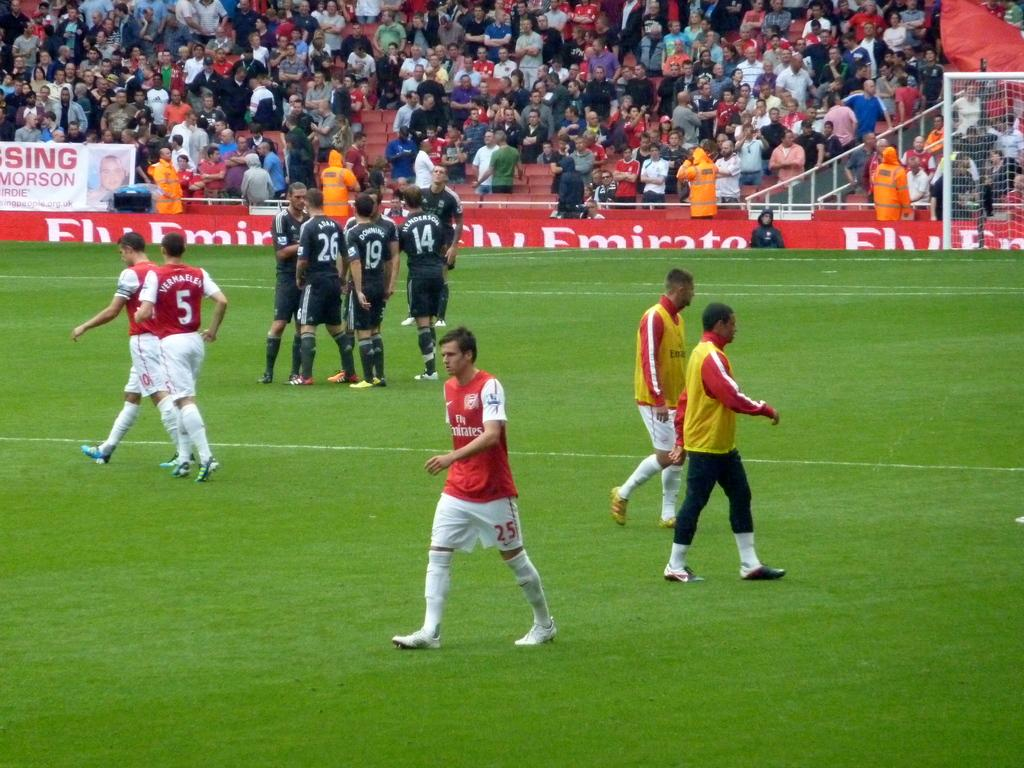<image>
Give a short and clear explanation of the subsequent image. Fly Emirate sponsors the red team playing soccer. 